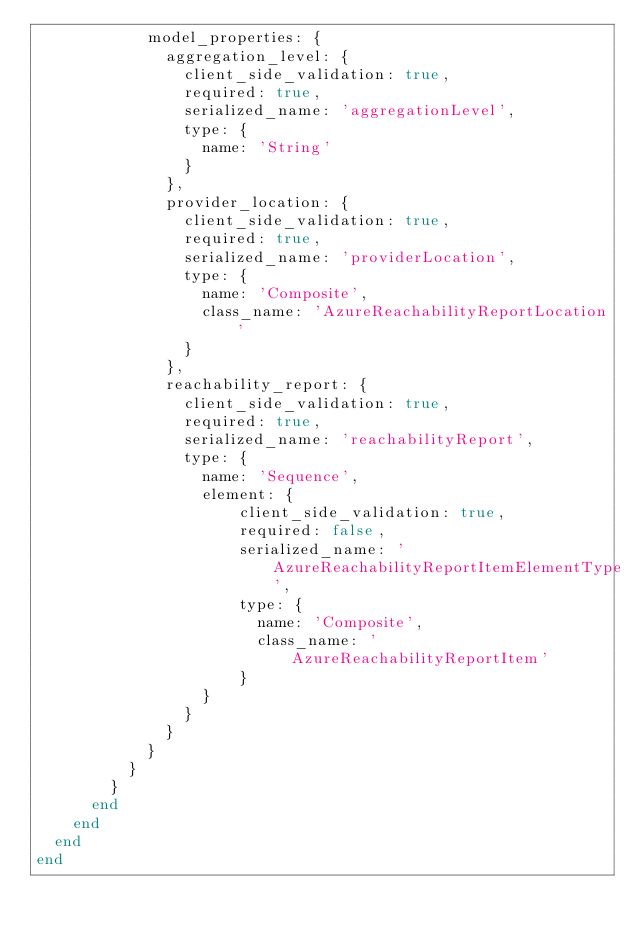Convert code to text. <code><loc_0><loc_0><loc_500><loc_500><_Ruby_>            model_properties: {
              aggregation_level: {
                client_side_validation: true,
                required: true,
                serialized_name: 'aggregationLevel',
                type: {
                  name: 'String'
                }
              },
              provider_location: {
                client_side_validation: true,
                required: true,
                serialized_name: 'providerLocation',
                type: {
                  name: 'Composite',
                  class_name: 'AzureReachabilityReportLocation'
                }
              },
              reachability_report: {
                client_side_validation: true,
                required: true,
                serialized_name: 'reachabilityReport',
                type: {
                  name: 'Sequence',
                  element: {
                      client_side_validation: true,
                      required: false,
                      serialized_name: 'AzureReachabilityReportItemElementType',
                      type: {
                        name: 'Composite',
                        class_name: 'AzureReachabilityReportItem'
                      }
                  }
                }
              }
            }
          }
        }
      end
    end
  end
end
</code> 